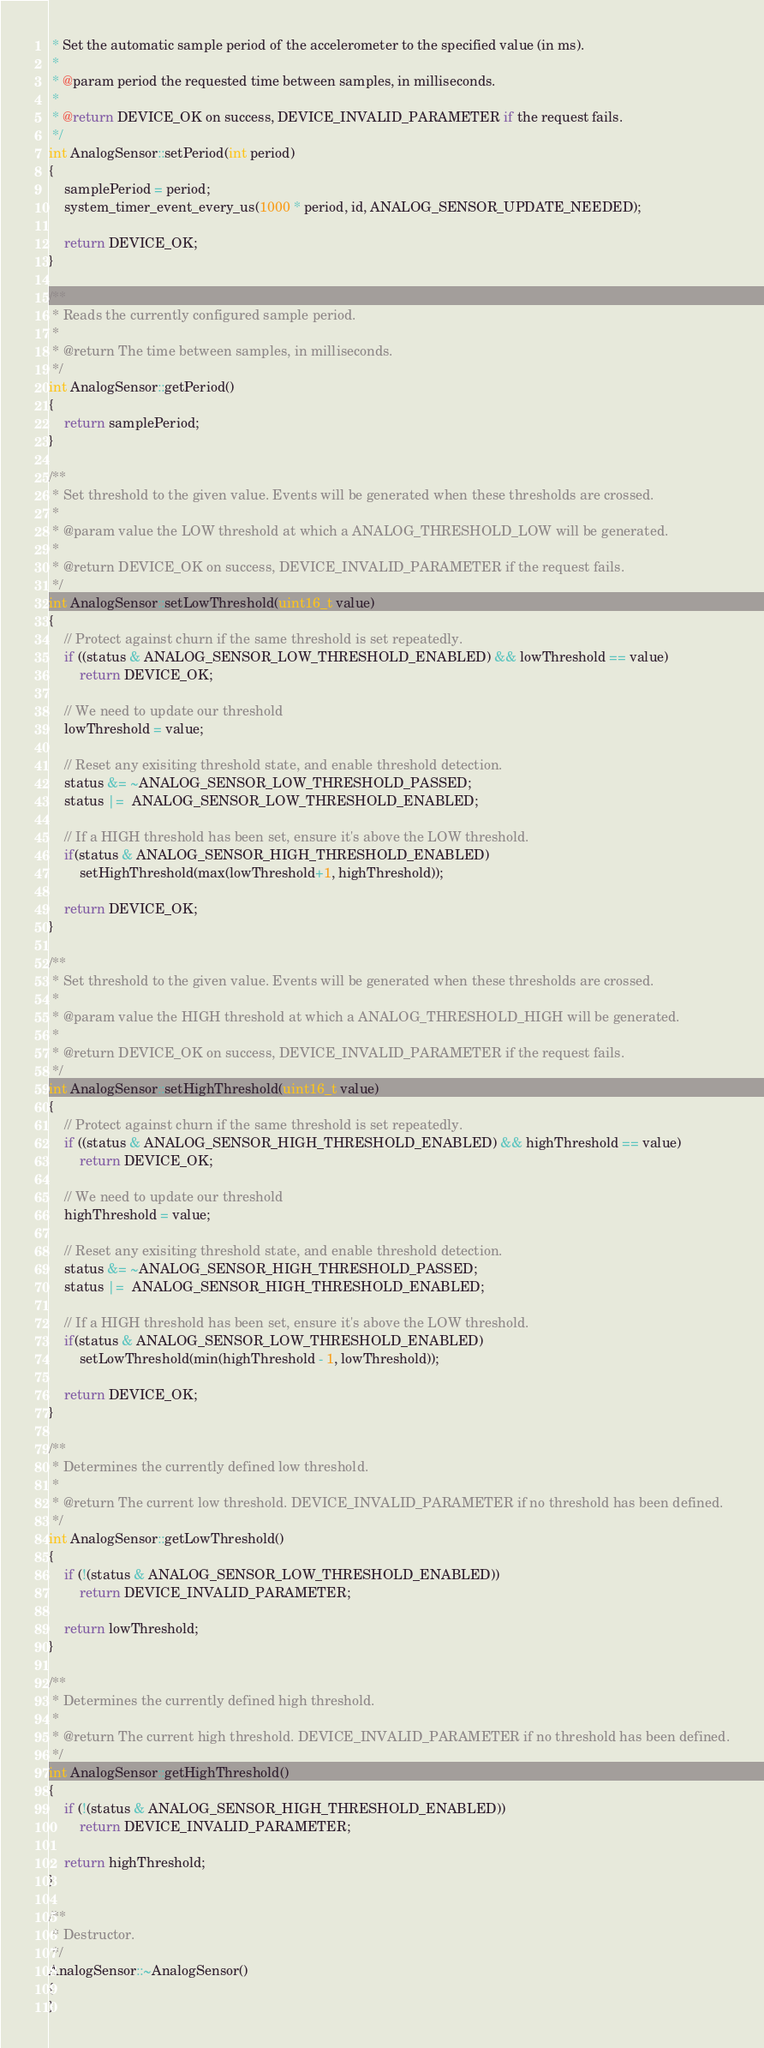<code> <loc_0><loc_0><loc_500><loc_500><_C++_> * Set the automatic sample period of the accelerometer to the specified value (in ms).
 *
 * @param period the requested time between samples, in milliseconds.
 *
 * @return DEVICE_OK on success, DEVICE_INVALID_PARAMETER if the request fails.
 */
int AnalogSensor::setPeriod(int period)
{
    samplePeriod = period;
    system_timer_event_every_us(1000 * period, id, ANALOG_SENSOR_UPDATE_NEEDED);

    return DEVICE_OK;
}

/**
 * Reads the currently configured sample period.
 *
 * @return The time between samples, in milliseconds.
 */
int AnalogSensor::getPeriod()
{
    return samplePeriod;
}

/**
 * Set threshold to the given value. Events will be generated when these thresholds are crossed.
 *
 * @param value the LOW threshold at which a ANALOG_THRESHOLD_LOW will be generated.
 *
 * @return DEVICE_OK on success, DEVICE_INVALID_PARAMETER if the request fails.
 */
int AnalogSensor::setLowThreshold(uint16_t value)
{
    // Protect against churn if the same threshold is set repeatedly.
    if ((status & ANALOG_SENSOR_LOW_THRESHOLD_ENABLED) && lowThreshold == value)
        return DEVICE_OK;

    // We need to update our threshold
    lowThreshold = value;

    // Reset any exisiting threshold state, and enable threshold detection.
    status &= ~ANALOG_SENSOR_LOW_THRESHOLD_PASSED;
    status |=  ANALOG_SENSOR_LOW_THRESHOLD_ENABLED;

    // If a HIGH threshold has been set, ensure it's above the LOW threshold.
    if(status & ANALOG_SENSOR_HIGH_THRESHOLD_ENABLED)
        setHighThreshold(max(lowThreshold+1, highThreshold));

    return DEVICE_OK;
}

/**
 * Set threshold to the given value. Events will be generated when these thresholds are crossed.
 *
 * @param value the HIGH threshold at which a ANALOG_THRESHOLD_HIGH will be generated.
 *
 * @return DEVICE_OK on success, DEVICE_INVALID_PARAMETER if the request fails.
 */
int AnalogSensor::setHighThreshold(uint16_t value)
{
    // Protect against churn if the same threshold is set repeatedly.
    if ((status & ANALOG_SENSOR_HIGH_THRESHOLD_ENABLED) && highThreshold == value)
        return DEVICE_OK;

    // We need to update our threshold
    highThreshold = value;

    // Reset any exisiting threshold state, and enable threshold detection.
    status &= ~ANALOG_SENSOR_HIGH_THRESHOLD_PASSED;
    status |=  ANALOG_SENSOR_HIGH_THRESHOLD_ENABLED;

    // If a HIGH threshold has been set, ensure it's above the LOW threshold.
    if(status & ANALOG_SENSOR_LOW_THRESHOLD_ENABLED)
        setLowThreshold(min(highThreshold - 1, lowThreshold));

    return DEVICE_OK;
}

/**
 * Determines the currently defined low threshold.
 *
 * @return The current low threshold. DEVICE_INVALID_PARAMETER if no threshold has been defined.
 */
int AnalogSensor::getLowThreshold()
{
    if (!(status & ANALOG_SENSOR_LOW_THRESHOLD_ENABLED))
        return DEVICE_INVALID_PARAMETER;

    return lowThreshold;
}

/**
 * Determines the currently defined high threshold.
 *
 * @return The current high threshold. DEVICE_INVALID_PARAMETER if no threshold has been defined.
 */
int AnalogSensor::getHighThreshold()
{
    if (!(status & ANALOG_SENSOR_HIGH_THRESHOLD_ENABLED))
        return DEVICE_INVALID_PARAMETER;

    return highThreshold;
}

/**
 * Destructor.
 */
AnalogSensor::~AnalogSensor()
{
}
</code> 